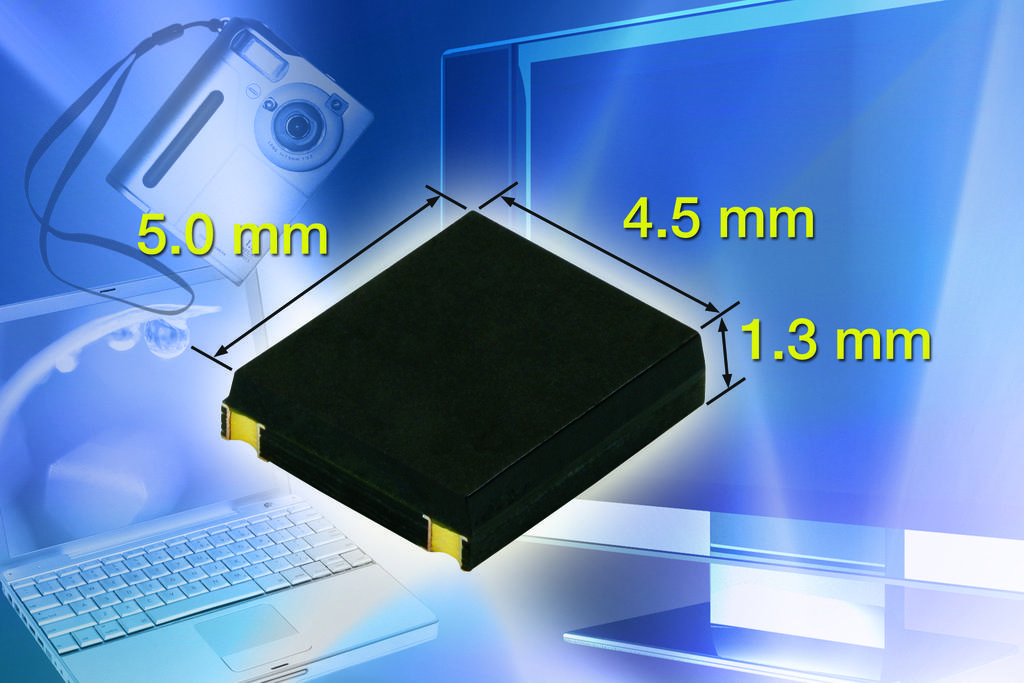What type of image is being described? The image is graphical. What is the main subject of the image? There is a picture of a laptop in the image. What is the laptop displaying in the image? There is a screen in the image. What device is present in the image that can capture images or videos? There is a camera in the image. What is the general purpose of the object in the image? There is an object in the image, but its purpose is not specified. What additional information is provided in the image? There is text written on the image. How does the sheet of paper interact with the laptop in the image? There is no sheet of paper present in the image. What type of breath is being captured by the camera in the image? There is no breath being captured by the camera in the image; it is a device for capturing images or videos. 